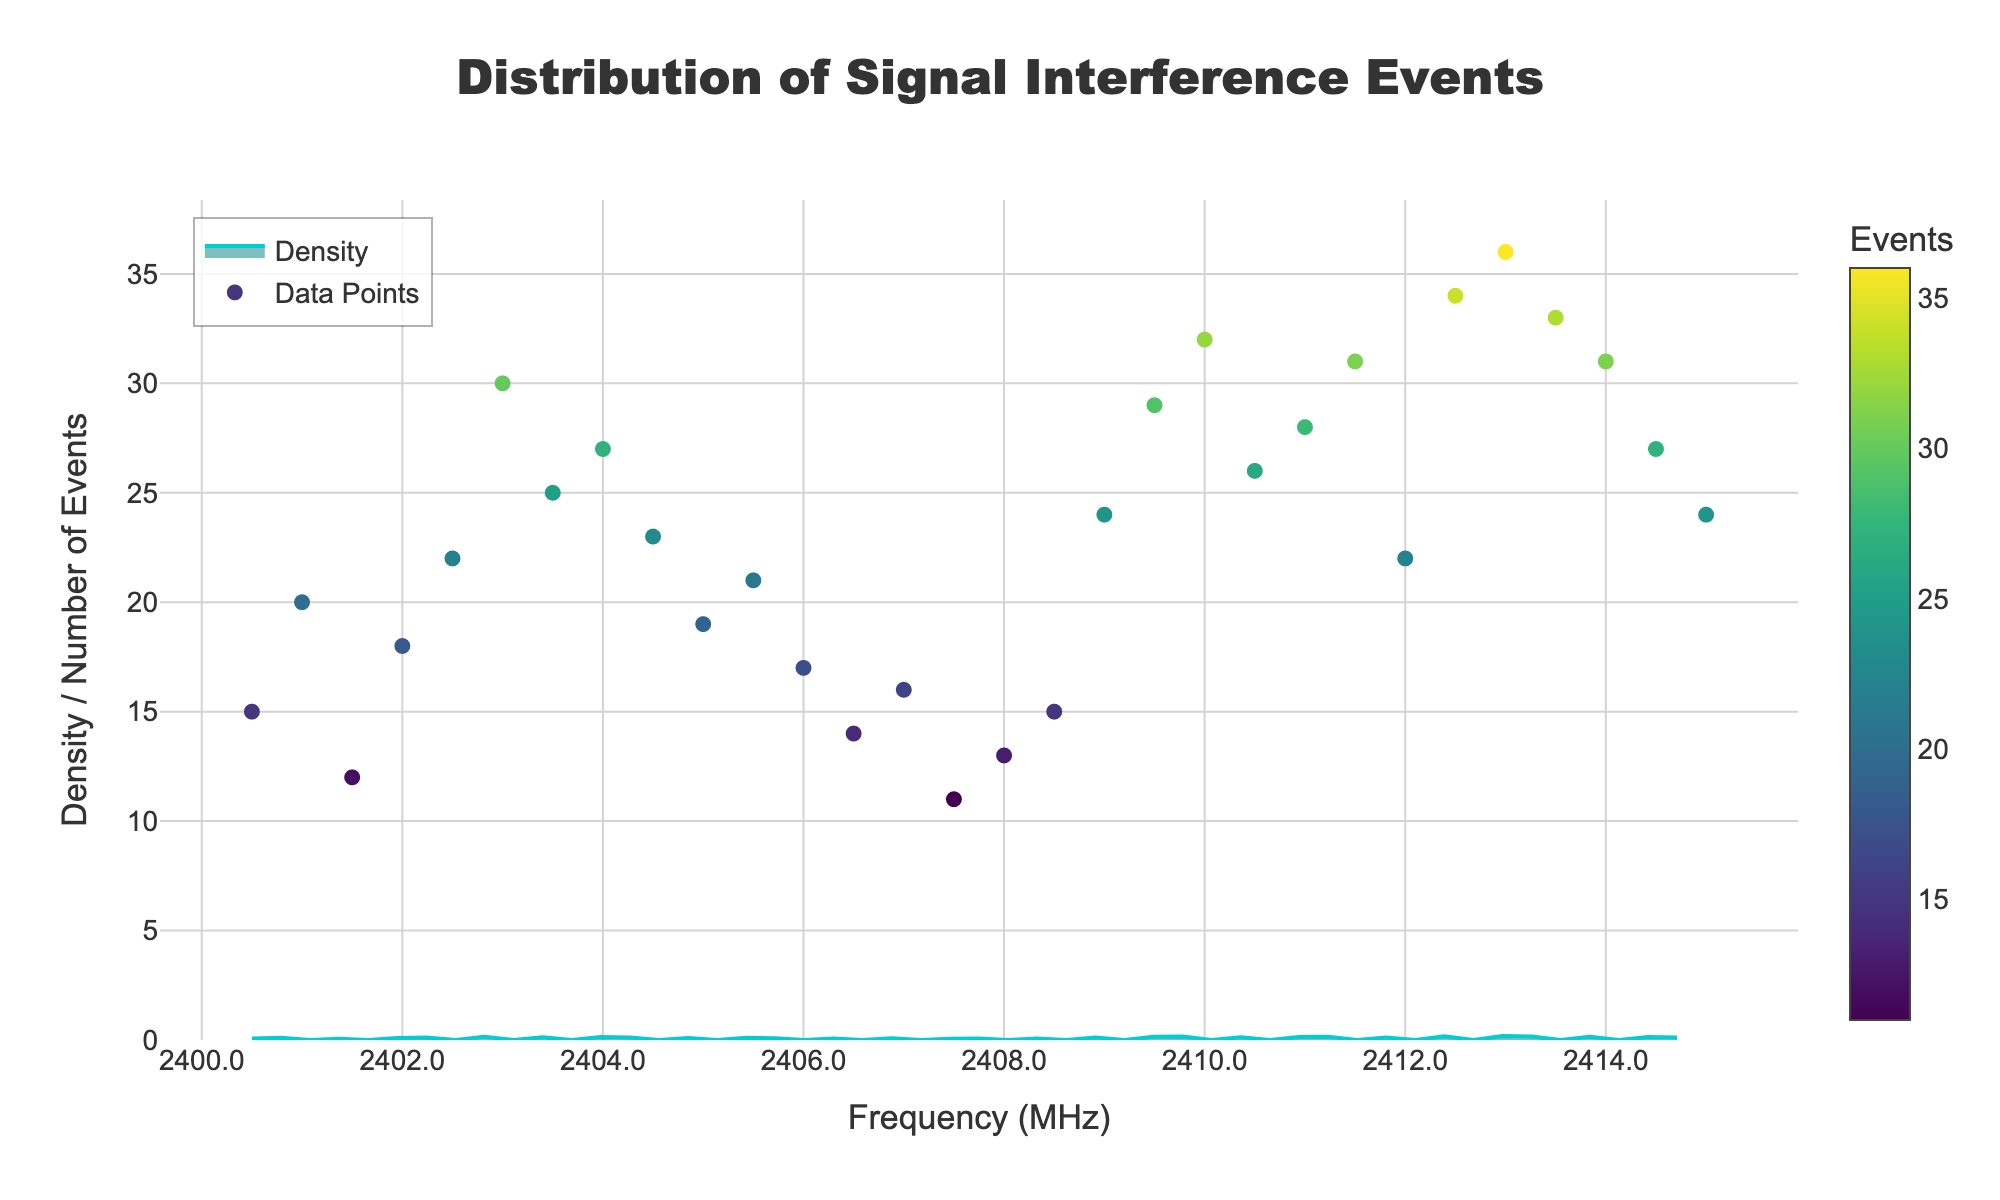what is the title of the plot? The title is located at the top of the figure and describes the main subject of the plot.
Answer: Distribution of Signal Interference Events what is the x-axis title? The x-axis title appears below the x-axis, indicating the dimension being measured.
Answer: Frequency (MHz) how many data points are there in the scatter plot? The scatter plot shows individual data points. By counting them or referring to the data table, we know there are 30 data points.
Answer: 30 which frequency range has the highest density of interference events? By examining the density plot, the highest peak represents the frequency with the maximum density. Look for the highest point.
Answer: 2413.0 MHz at which frequency is the peak of interference events? Find the peak in the scatter plot where there is the highest number of interference events.
Answer: 2413.0 MHz what is the minimum number of interference events recorded at any frequency? Identify the lowest point on the scatter plot, representing the minimum number of interference events. The minimum value is also listed in the data table.
Answer: 11 between which frequencies is the interference density relatively stable? Look for sections of the density plot where the density does not drastically change.
Answer: 2401.0 MHz to 2408.5 MHz which frequency has more interference events: 2405.0 MHz or 2412.0 MHz? Compare the interference events at these two frequencies based on their y-values in the scatter plot.
Answer: 2412.0 MHz what is the average number of interference events across all frequencies? Sum all the y-values (Interference_Events) and divide by the total number of frequencies (data points). (15 + 20 + 12 + ... + 24)/30 = 23.1
Answer: 23.1 how does the density plot indicate the presence of outliers or anomalies? Identify unusually high peaks or sharp declines in the density plot that signify significant deviations from the general pattern.
Answer: High peaks and sharp declines 